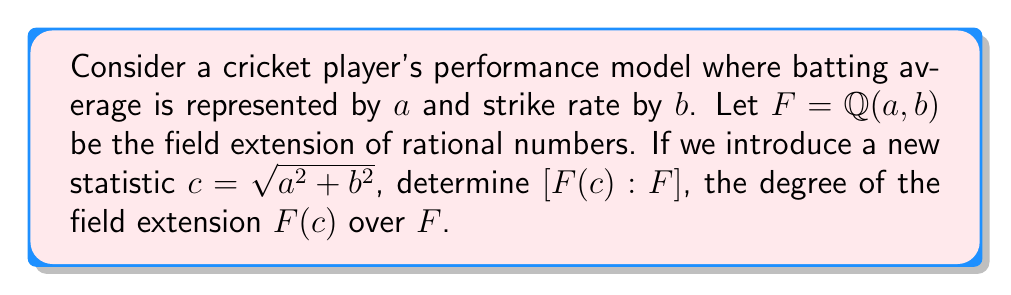Can you solve this math problem? To solve this problem, we'll follow these steps:

1) First, we need to determine if $c$ is algebraic over $F$. We can do this by finding a polynomial with coefficients in $F$ that has $c$ as a root.

2) We can rearrange the equation $c = \sqrt{a^2 + b^2}$ to get:
   $$c^2 = a^2 + b^2$$

3) This can be rewritten as:
   $$c^2 - (a^2 + b^2) = 0$$

4) This is a polynomial equation with coefficients in $F$, and $c$ is a root of this polynomial. Therefore, $c$ is algebraic over $F$.

5) The polynomial $p(x) = x^2 - (a^2 + b^2)$ is the minimal polynomial of $c$ over $F$, because:
   - It's monic (leading coefficient is 1)
   - It has $c$ as a root
   - It's irreducible over $F$ (it can't be factored further using elements from $F$)

6) The degree of the minimal polynomial is 2.

7) For any algebraic extension, the degree of the extension is equal to the degree of the minimal polynomial of the adjoined element.

Therefore, $[F(c):F] = 2$.
Answer: $[F(c):F] = 2$ 